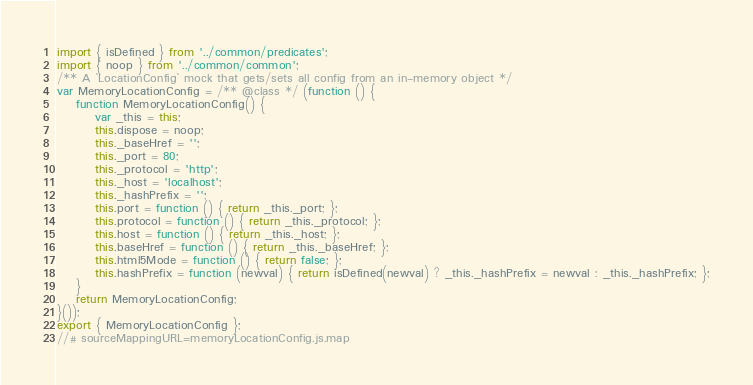Convert code to text. <code><loc_0><loc_0><loc_500><loc_500><_JavaScript_>import { isDefined } from '../common/predicates';
import { noop } from '../common/common';
/** A `LocationConfig` mock that gets/sets all config from an in-memory object */
var MemoryLocationConfig = /** @class */ (function () {
    function MemoryLocationConfig() {
        var _this = this;
        this.dispose = noop;
        this._baseHref = '';
        this._port = 80;
        this._protocol = 'http';
        this._host = 'localhost';
        this._hashPrefix = '';
        this.port = function () { return _this._port; };
        this.protocol = function () { return _this._protocol; };
        this.host = function () { return _this._host; };
        this.baseHref = function () { return _this._baseHref; };
        this.html5Mode = function () { return false; };
        this.hashPrefix = function (newval) { return isDefined(newval) ? _this._hashPrefix = newval : _this._hashPrefix; };
    }
    return MemoryLocationConfig;
}());
export { MemoryLocationConfig };
//# sourceMappingURL=memoryLocationConfig.js.map</code> 